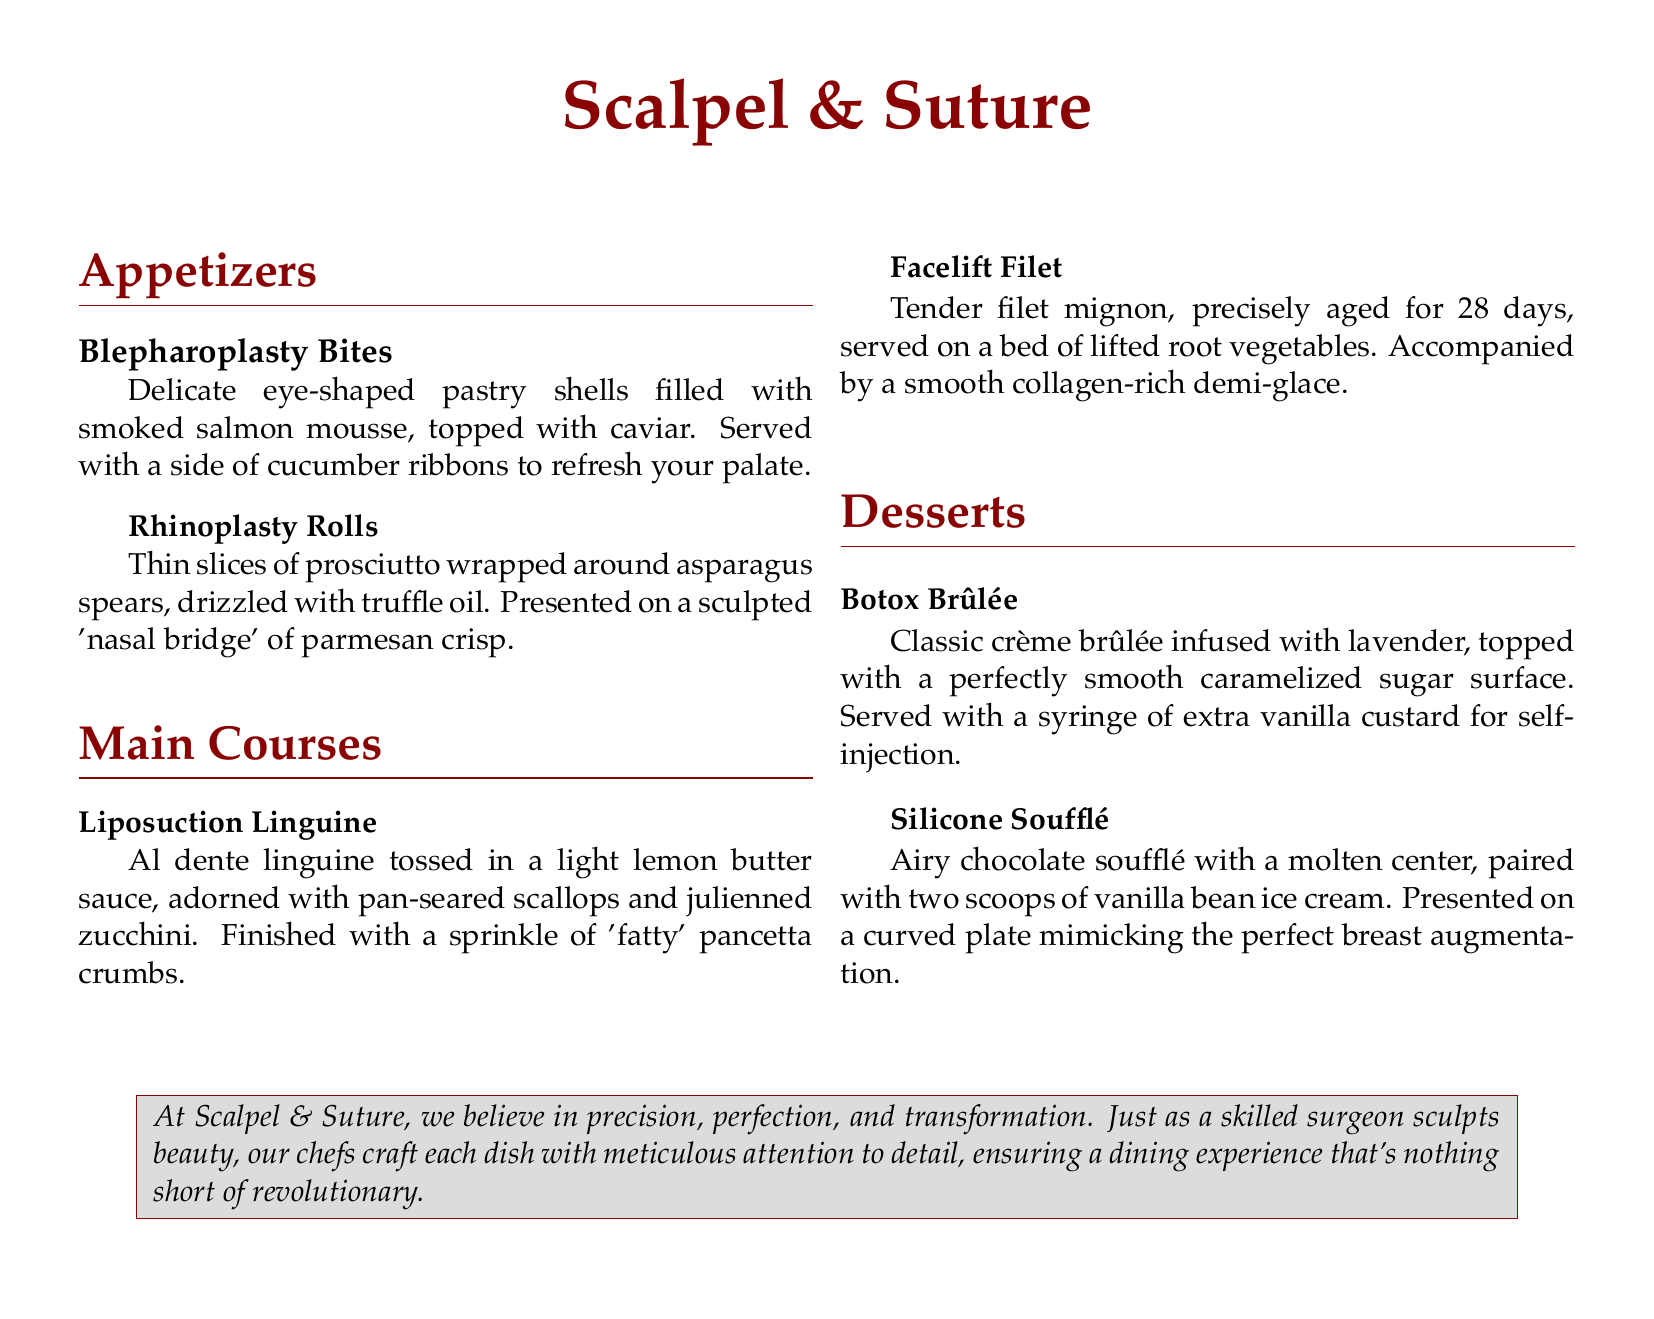What is the name of the restaurant? The name of the restaurant is prominently displayed as the title of the document.
Answer: Scalpel & Suture How many appetizers are listed on the menu? The appetizers section contains two distinct dishes.
Answer: 2 What is the main ingredient in Blepharoplasty Bites? The primary filling of Blepharoplasty Bites, as described, is smoked salmon mousse.
Answer: Smoked salmon mousse What is served with the Facelift Filet? The Facelift Filet is accompanied by a specific type of sauce and vegetables.
Answer: Collagen-rich demi-glace What dessert features a lavender infusion? One of the desserts is specifically noted for its infusion of a certain herb.
Answer: Botox Brûlée Which dish includes scallops? The main course that includes scallops is specified in the description.
Answer: Liposuction Linguine What preparation style is indicated for the filet mignon? The description includes details on the aging process of the filet mignon.
Answer: Precisely aged for 28 days What is the unique serving feature of the Botox Brûlée? The dessert is served with an unusual accompaniment that enhances the dining experience.
Answer: Syringe of extra vanilla custard How are the appetizers described in relation to their presentation? The appetizers section mentions a specific aspect of presentation that distinguishes them.
Answer: Eye-shaped pastry shells 